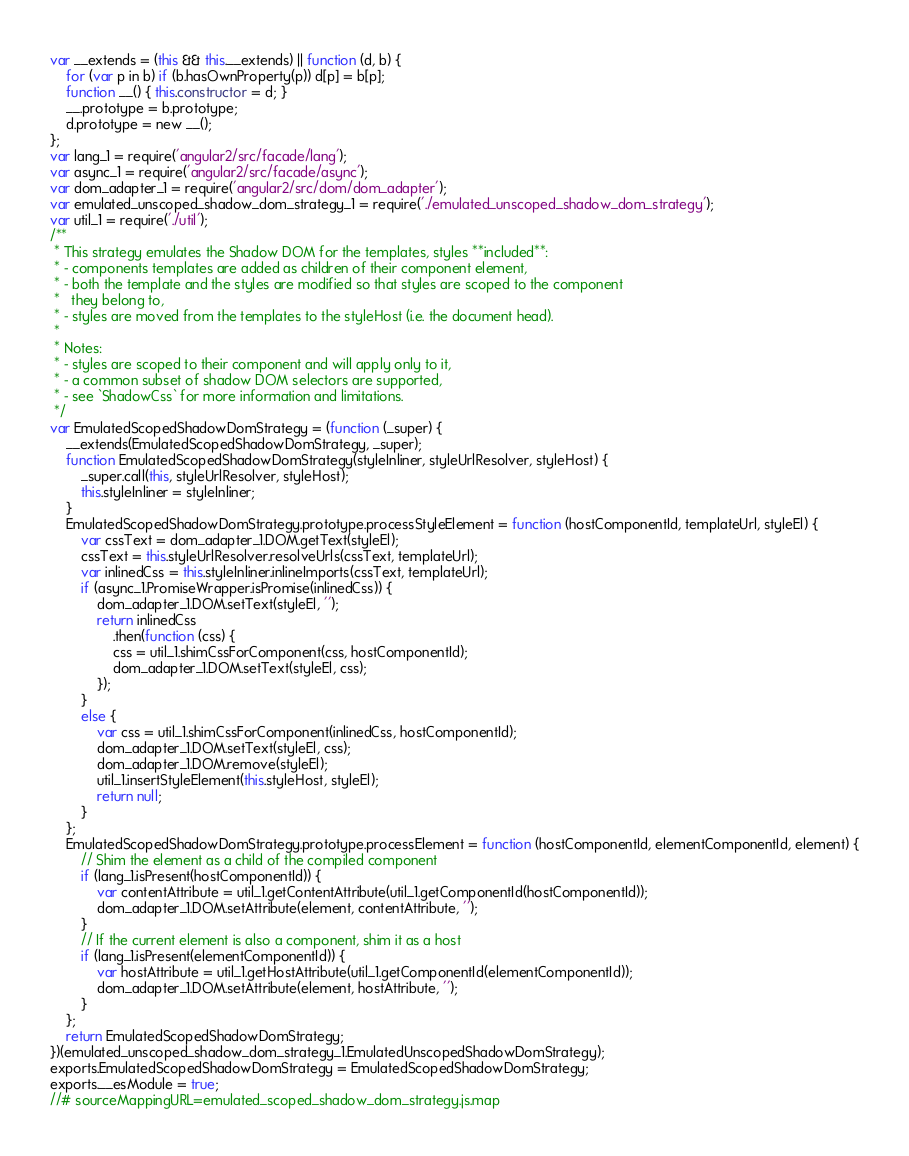Convert code to text. <code><loc_0><loc_0><loc_500><loc_500><_JavaScript_>var __extends = (this && this.__extends) || function (d, b) {
    for (var p in b) if (b.hasOwnProperty(p)) d[p] = b[p];
    function __() { this.constructor = d; }
    __.prototype = b.prototype;
    d.prototype = new __();
};
var lang_1 = require('angular2/src/facade/lang');
var async_1 = require('angular2/src/facade/async');
var dom_adapter_1 = require('angular2/src/dom/dom_adapter');
var emulated_unscoped_shadow_dom_strategy_1 = require('./emulated_unscoped_shadow_dom_strategy');
var util_1 = require('./util');
/**
 * This strategy emulates the Shadow DOM for the templates, styles **included**:
 * - components templates are added as children of their component element,
 * - both the template and the styles are modified so that styles are scoped to the component
 *   they belong to,
 * - styles are moved from the templates to the styleHost (i.e. the document head).
 *
 * Notes:
 * - styles are scoped to their component and will apply only to it,
 * - a common subset of shadow DOM selectors are supported,
 * - see `ShadowCss` for more information and limitations.
 */
var EmulatedScopedShadowDomStrategy = (function (_super) {
    __extends(EmulatedScopedShadowDomStrategy, _super);
    function EmulatedScopedShadowDomStrategy(styleInliner, styleUrlResolver, styleHost) {
        _super.call(this, styleUrlResolver, styleHost);
        this.styleInliner = styleInliner;
    }
    EmulatedScopedShadowDomStrategy.prototype.processStyleElement = function (hostComponentId, templateUrl, styleEl) {
        var cssText = dom_adapter_1.DOM.getText(styleEl);
        cssText = this.styleUrlResolver.resolveUrls(cssText, templateUrl);
        var inlinedCss = this.styleInliner.inlineImports(cssText, templateUrl);
        if (async_1.PromiseWrapper.isPromise(inlinedCss)) {
            dom_adapter_1.DOM.setText(styleEl, '');
            return inlinedCss
                .then(function (css) {
                css = util_1.shimCssForComponent(css, hostComponentId);
                dom_adapter_1.DOM.setText(styleEl, css);
            });
        }
        else {
            var css = util_1.shimCssForComponent(inlinedCss, hostComponentId);
            dom_adapter_1.DOM.setText(styleEl, css);
            dom_adapter_1.DOM.remove(styleEl);
            util_1.insertStyleElement(this.styleHost, styleEl);
            return null;
        }
    };
    EmulatedScopedShadowDomStrategy.prototype.processElement = function (hostComponentId, elementComponentId, element) {
        // Shim the element as a child of the compiled component
        if (lang_1.isPresent(hostComponentId)) {
            var contentAttribute = util_1.getContentAttribute(util_1.getComponentId(hostComponentId));
            dom_adapter_1.DOM.setAttribute(element, contentAttribute, '');
        }
        // If the current element is also a component, shim it as a host
        if (lang_1.isPresent(elementComponentId)) {
            var hostAttribute = util_1.getHostAttribute(util_1.getComponentId(elementComponentId));
            dom_adapter_1.DOM.setAttribute(element, hostAttribute, '');
        }
    };
    return EmulatedScopedShadowDomStrategy;
})(emulated_unscoped_shadow_dom_strategy_1.EmulatedUnscopedShadowDomStrategy);
exports.EmulatedScopedShadowDomStrategy = EmulatedScopedShadowDomStrategy;
exports.__esModule = true;
//# sourceMappingURL=emulated_scoped_shadow_dom_strategy.js.map</code> 